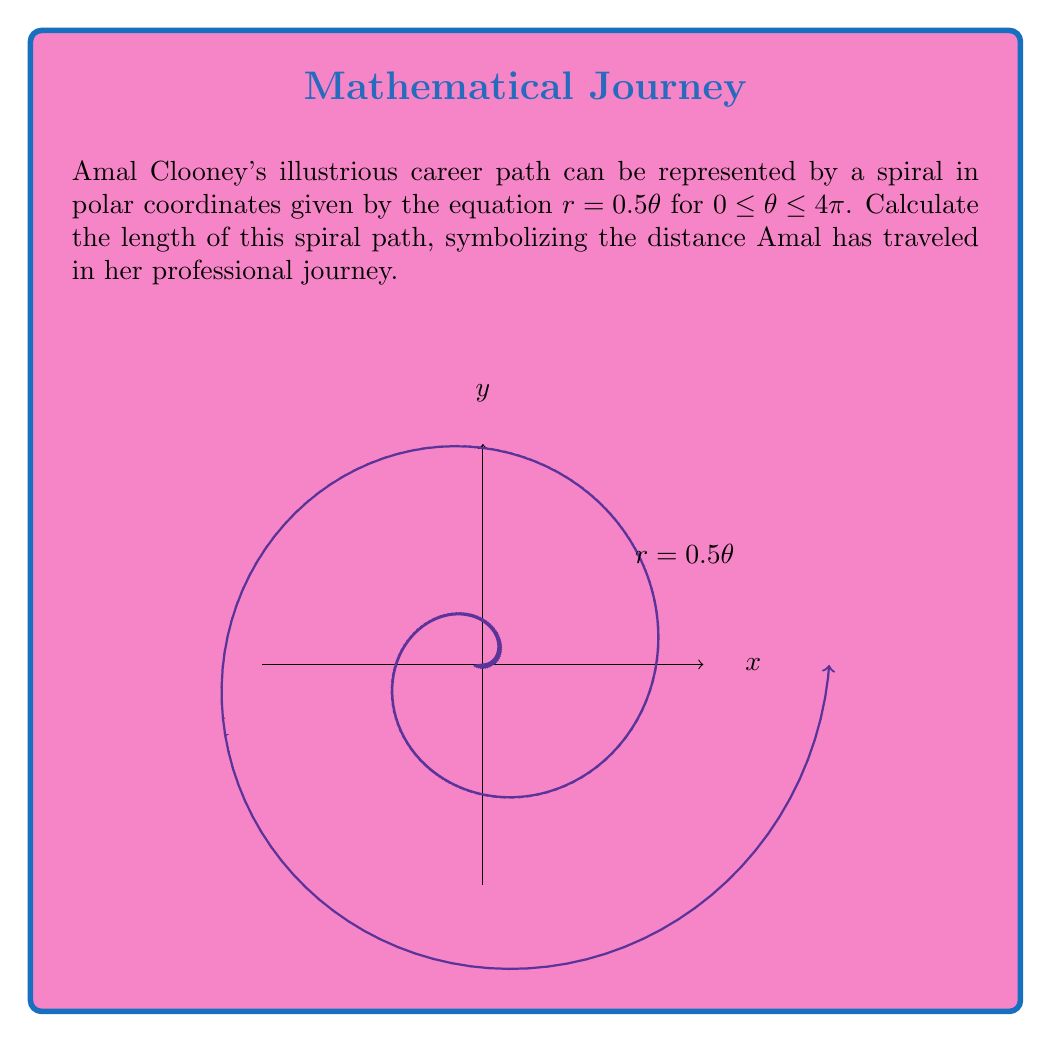Can you answer this question? To find the length of the spiral path, we need to use the arc length formula for polar curves:

$$L = \int_a^b \sqrt{r^2 + \left(\frac{dr}{d\theta}\right)^2} d\theta$$

Given: $r = 0.5\theta$, $0 \leq \theta \leq 4\pi$

Step 1: Find $\frac{dr}{d\theta}$
$$\frac{dr}{d\theta} = 0.5$$

Step 2: Substitute into the arc length formula
$$L = \int_0^{4\pi} \sqrt{(0.5\theta)^2 + (0.5)^2} d\theta$$

Step 3: Simplify under the square root
$$L = \int_0^{4\pi} \sqrt{0.25\theta^2 + 0.25} d\theta$$
$$L = 0.5 \int_0^{4\pi} \sqrt{\theta^2 + 1} d\theta$$

Step 4: This integral can be solved using the substitution $\theta = \sinh u$
Let $\theta = \sinh u$, then $d\theta = \cosh u \, du$
When $\theta = 0$, $u = 0$
When $\theta = 4\pi$, $u = \sinh^{-1}(4\pi)$

$$L = 0.5 \int_0^{\sinh^{-1}(4\pi)} \sqrt{\sinh^2 u + 1} \cosh u \, du$$

Step 5: Simplify using the identity $\sinh^2 u + 1 = \cosh^2 u$
$$L = 0.5 \int_0^{\sinh^{-1}(4\pi)} \cosh^2 u \, du$$

Step 6: Use the identity $\cosh^2 u = \frac{1}{2}(\cosh 2u + 1)$
$$L = 0.25 \int_0^{\sinh^{-1}(4\pi)} (\cosh 2u + 1) \, du$$

Step 7: Integrate
$$L = 0.25 \left[\frac{1}{2}\sinh 2u + u\right]_0^{\sinh^{-1}(4\pi)}$$

Step 8: Evaluate the limits
$$L = 0.25 \left[\frac{1}{2}\sinh(2\sinh^{-1}(4\pi)) + \sinh^{-1}(4\pi)\right]$$

Step 9: Simplify using the identity $\sinh(2\sinh^{-1}x) = 2x\sqrt{1+x^2}$
$$L = 0.25 \left[4\pi\sqrt{1+(4\pi)^2} + \sinh^{-1}(4\pi)\right]$$
Answer: $0.25 [4\pi\sqrt{1+(4\pi)^2} + \sinh^{-1}(4\pi)]$ 